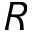<formula> <loc_0><loc_0><loc_500><loc_500>R</formula> 